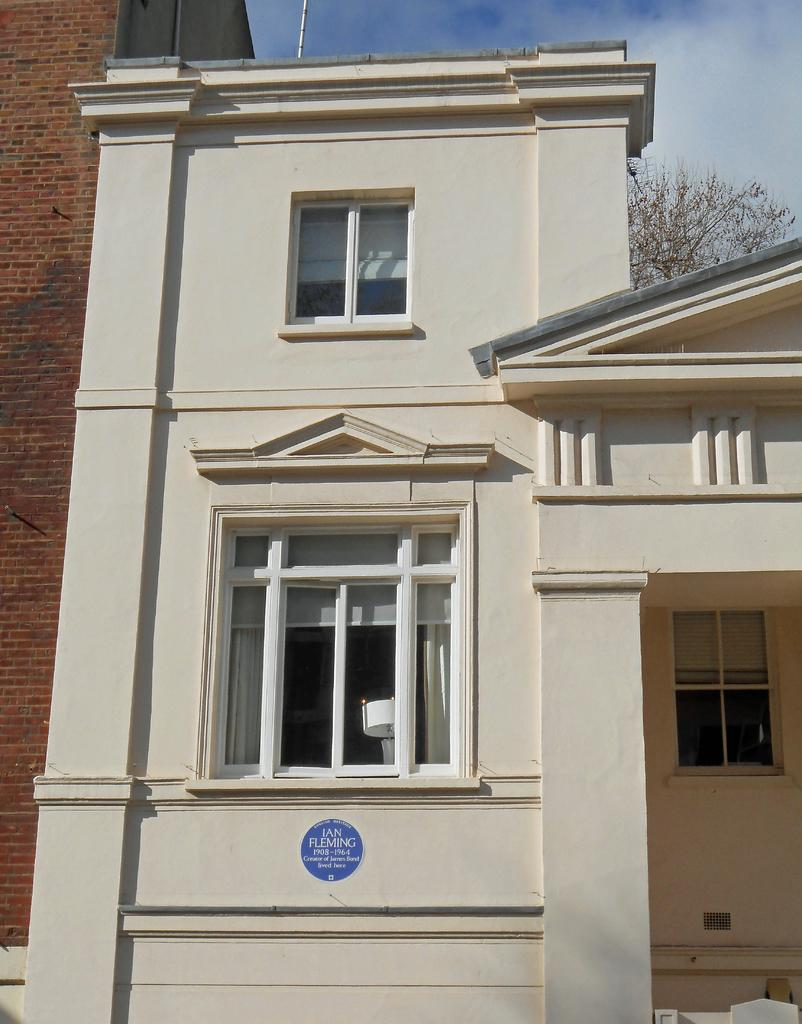What type of building is in the image? There is a white building in the image. What is the material of the wall visible in the image? There is a brick wall in the image. What type of natural element is visible in the image? There is a tree visible in the image. Where is the park located in the image? There is no park present in the image. What type of music can be heard playing in the background of the image? There is no music present in the image. 